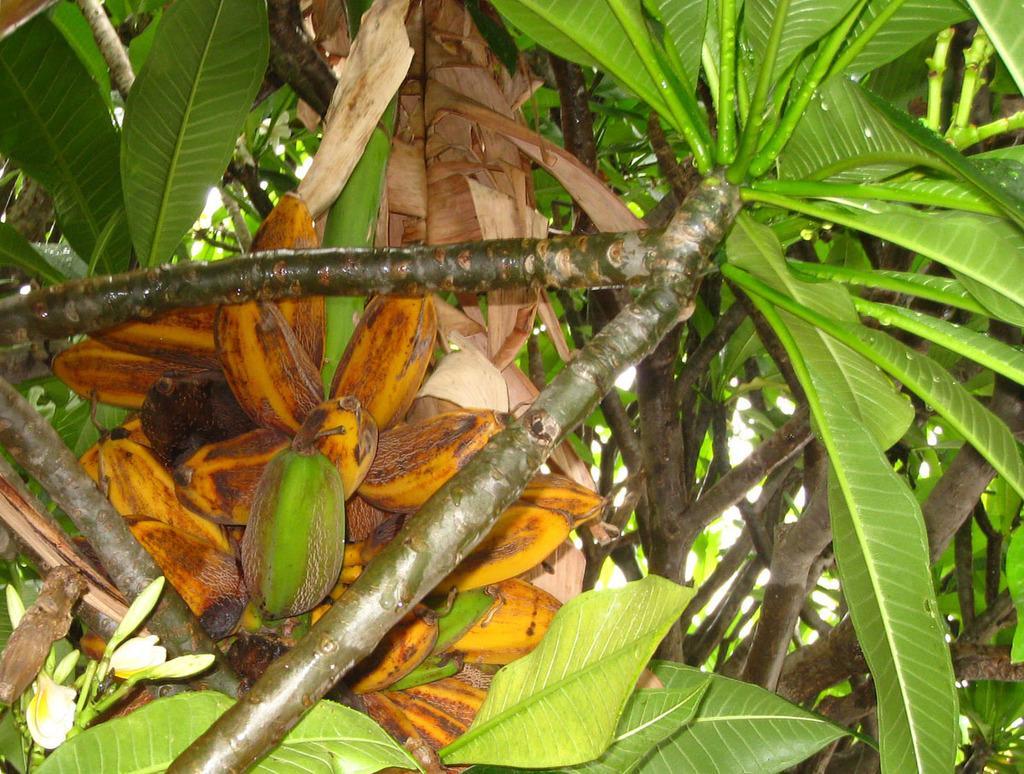Please provide a concise description of this image. In the picture there are fruits present in the tree. 